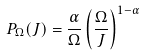Convert formula to latex. <formula><loc_0><loc_0><loc_500><loc_500>P _ { \Omega } ( J ) = \frac { \alpha } { \Omega } \left ( \frac { \Omega } { J } \right ) ^ { 1 - \alpha }</formula> 